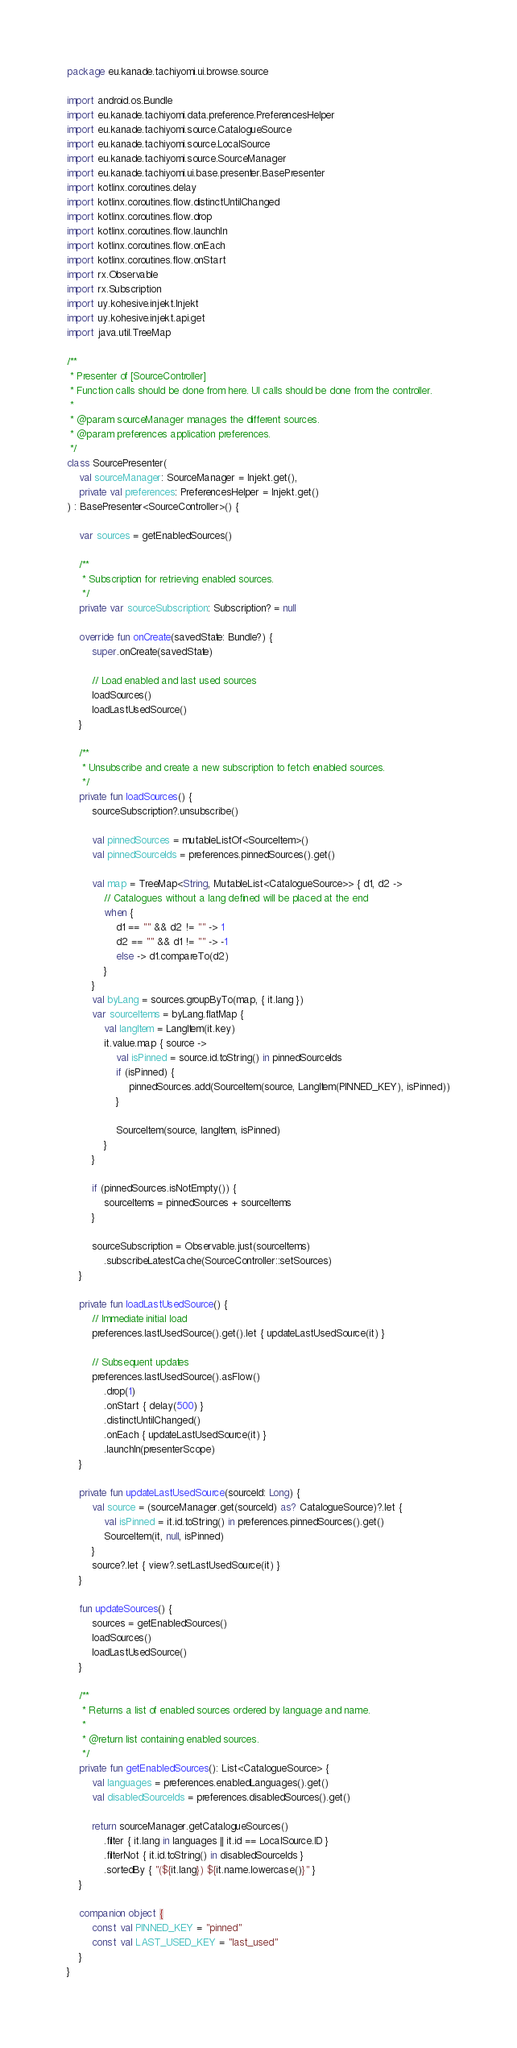Convert code to text. <code><loc_0><loc_0><loc_500><loc_500><_Kotlin_>package eu.kanade.tachiyomi.ui.browse.source

import android.os.Bundle
import eu.kanade.tachiyomi.data.preference.PreferencesHelper
import eu.kanade.tachiyomi.source.CatalogueSource
import eu.kanade.tachiyomi.source.LocalSource
import eu.kanade.tachiyomi.source.SourceManager
import eu.kanade.tachiyomi.ui.base.presenter.BasePresenter
import kotlinx.coroutines.delay
import kotlinx.coroutines.flow.distinctUntilChanged
import kotlinx.coroutines.flow.drop
import kotlinx.coroutines.flow.launchIn
import kotlinx.coroutines.flow.onEach
import kotlinx.coroutines.flow.onStart
import rx.Observable
import rx.Subscription
import uy.kohesive.injekt.Injekt
import uy.kohesive.injekt.api.get
import java.util.TreeMap

/**
 * Presenter of [SourceController]
 * Function calls should be done from here. UI calls should be done from the controller.
 *
 * @param sourceManager manages the different sources.
 * @param preferences application preferences.
 */
class SourcePresenter(
    val sourceManager: SourceManager = Injekt.get(),
    private val preferences: PreferencesHelper = Injekt.get()
) : BasePresenter<SourceController>() {

    var sources = getEnabledSources()

    /**
     * Subscription for retrieving enabled sources.
     */
    private var sourceSubscription: Subscription? = null

    override fun onCreate(savedState: Bundle?) {
        super.onCreate(savedState)

        // Load enabled and last used sources
        loadSources()
        loadLastUsedSource()
    }

    /**
     * Unsubscribe and create a new subscription to fetch enabled sources.
     */
    private fun loadSources() {
        sourceSubscription?.unsubscribe()

        val pinnedSources = mutableListOf<SourceItem>()
        val pinnedSourceIds = preferences.pinnedSources().get()

        val map = TreeMap<String, MutableList<CatalogueSource>> { d1, d2 ->
            // Catalogues without a lang defined will be placed at the end
            when {
                d1 == "" && d2 != "" -> 1
                d2 == "" && d1 != "" -> -1
                else -> d1.compareTo(d2)
            }
        }
        val byLang = sources.groupByTo(map, { it.lang })
        var sourceItems = byLang.flatMap {
            val langItem = LangItem(it.key)
            it.value.map { source ->
                val isPinned = source.id.toString() in pinnedSourceIds
                if (isPinned) {
                    pinnedSources.add(SourceItem(source, LangItem(PINNED_KEY), isPinned))
                }

                SourceItem(source, langItem, isPinned)
            }
        }

        if (pinnedSources.isNotEmpty()) {
            sourceItems = pinnedSources + sourceItems
        }

        sourceSubscription = Observable.just(sourceItems)
            .subscribeLatestCache(SourceController::setSources)
    }

    private fun loadLastUsedSource() {
        // Immediate initial load
        preferences.lastUsedSource().get().let { updateLastUsedSource(it) }

        // Subsequent updates
        preferences.lastUsedSource().asFlow()
            .drop(1)
            .onStart { delay(500) }
            .distinctUntilChanged()
            .onEach { updateLastUsedSource(it) }
            .launchIn(presenterScope)
    }

    private fun updateLastUsedSource(sourceId: Long) {
        val source = (sourceManager.get(sourceId) as? CatalogueSource)?.let {
            val isPinned = it.id.toString() in preferences.pinnedSources().get()
            SourceItem(it, null, isPinned)
        }
        source?.let { view?.setLastUsedSource(it) }
    }

    fun updateSources() {
        sources = getEnabledSources()
        loadSources()
        loadLastUsedSource()
    }

    /**
     * Returns a list of enabled sources ordered by language and name.
     *
     * @return list containing enabled sources.
     */
    private fun getEnabledSources(): List<CatalogueSource> {
        val languages = preferences.enabledLanguages().get()
        val disabledSourceIds = preferences.disabledSources().get()

        return sourceManager.getCatalogueSources()
            .filter { it.lang in languages || it.id == LocalSource.ID }
            .filterNot { it.id.toString() in disabledSourceIds }
            .sortedBy { "(${it.lang}) ${it.name.lowercase()}" }
    }

    companion object {
        const val PINNED_KEY = "pinned"
        const val LAST_USED_KEY = "last_used"
    }
}
</code> 